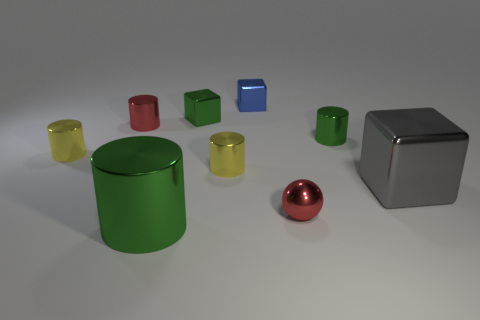Subtract all tiny shiny cubes. How many cubes are left? 1 Subtract all balls. How many objects are left? 8 Subtract 3 blocks. How many blocks are left? 0 Subtract all green blocks. How many blocks are left? 2 Subtract all red balls. How many green cylinders are left? 2 Subtract all tiny spheres. Subtract all yellow cylinders. How many objects are left? 6 Add 6 red metal things. How many red metal things are left? 8 Add 6 tiny red cylinders. How many tiny red cylinders exist? 7 Subtract 0 cyan blocks. How many objects are left? 9 Subtract all cyan cylinders. Subtract all blue cubes. How many cylinders are left? 5 